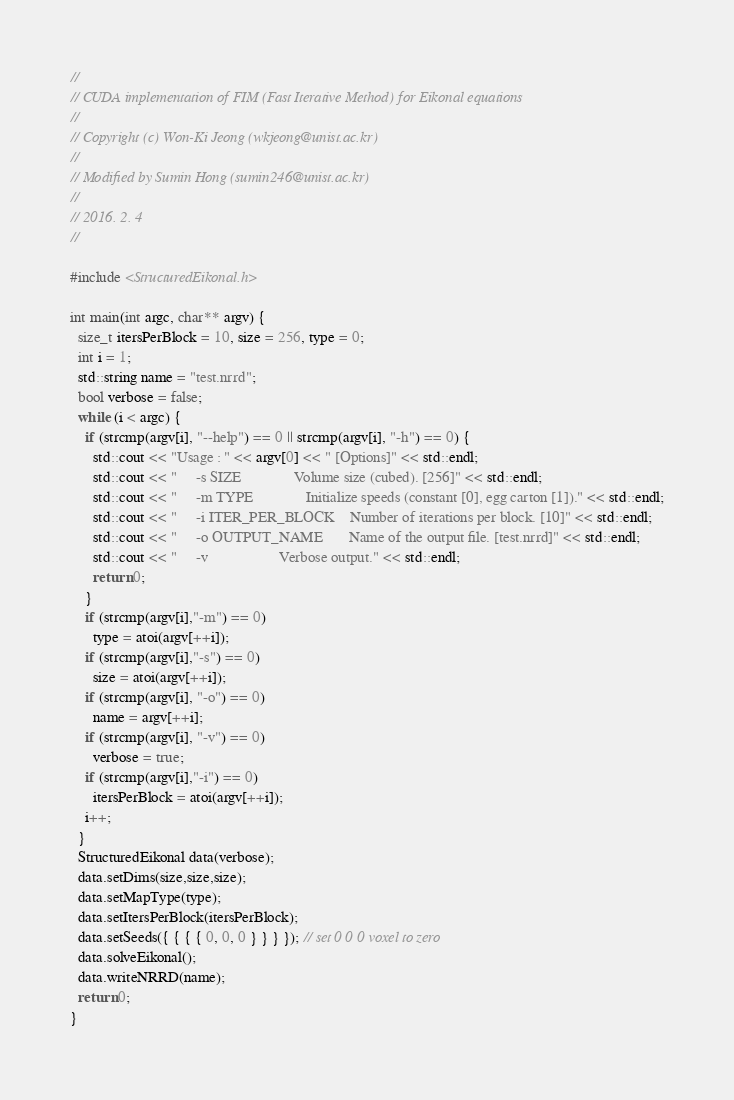Convert code to text. <code><loc_0><loc_0><loc_500><loc_500><_Cuda_>//
// CUDA implementation of FIM (Fast Iterative Method) for Eikonal equations
//
// Copyright (c) Won-Ki Jeong (wkjeong@unist.ac.kr)
//
// Modified by Sumin Hong (sumin246@unist.ac.kr)
//
// 2016. 2. 4
//

#include <StructuredEikonal.h>

int main(int argc, char** argv) {
  size_t itersPerBlock = 10, size = 256, type = 0;
  int i = 1;
  std::string name = "test.nrrd";
  bool verbose = false;
  while (i < argc) {
    if (strcmp(argv[i], "--help") == 0 || strcmp(argv[i], "-h") == 0) {
      std::cout << "Usage : " << argv[0] << " [Options]" << std::endl;
      std::cout << "     -s SIZE              Volume size (cubed). [256]" << std::endl;
      std::cout << "     -m TYPE              Initialize speeds (constant [0], egg carton [1])." << std::endl;
      std::cout << "     -i ITER_PER_BLOCK    Number of iterations per block. [10]" << std::endl;
      std::cout << "     -o OUTPUT_NAME       Name of the output file. [test.nrrd]" << std::endl;
      std::cout << "     -v                   Verbose output." << std::endl;
      return 0;
    }
    if (strcmp(argv[i],"-m") == 0)
      type = atoi(argv[++i]);
    if (strcmp(argv[i],"-s") == 0)
      size = atoi(argv[++i]);
    if (strcmp(argv[i], "-o") == 0)
      name = argv[++i];
    if (strcmp(argv[i], "-v") == 0)
      verbose = true;
    if (strcmp(argv[i],"-i") == 0)
      itersPerBlock = atoi(argv[++i]);
    i++;
  }
  StructuredEikonal data(verbose);
  data.setDims(size,size,size);
  data.setMapType(type);
  data.setItersPerBlock(itersPerBlock);
  data.setSeeds({ { { { 0, 0, 0 } } } }); // set 0 0 0 voxel to zero
  data.solveEikonal();
  data.writeNRRD(name);
  return 0;
}</code> 